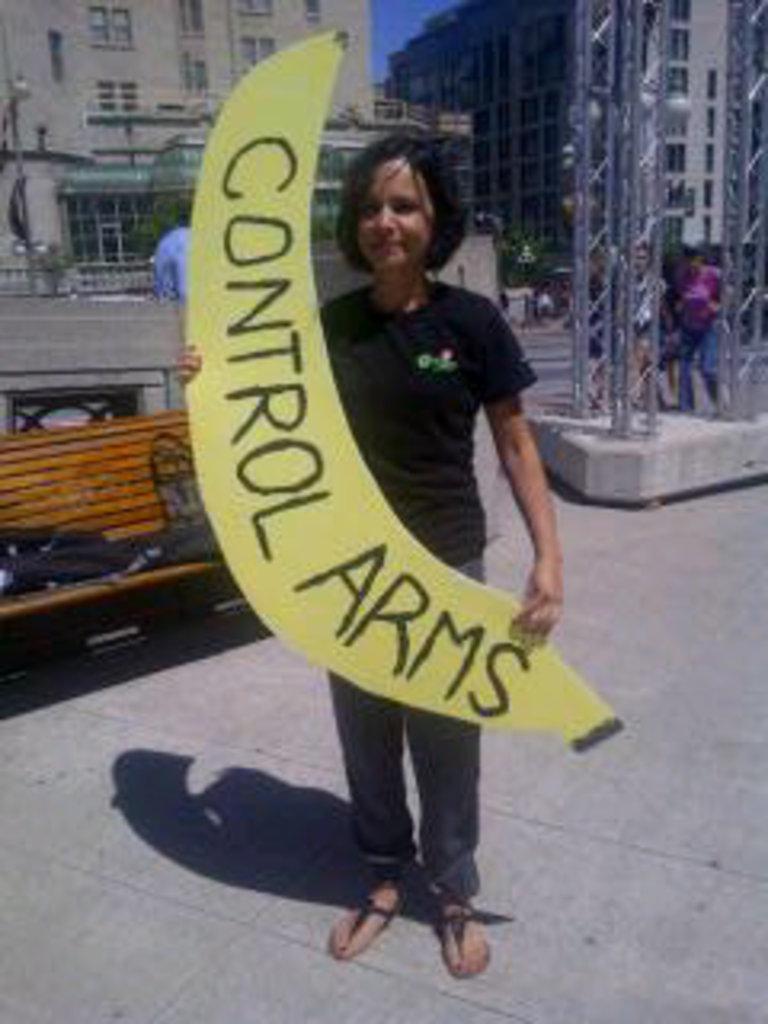Please provide a concise description of this image. As we can see in the image in the front there is a boy wearing black color t shirt and holding a banner. There is bench, few people here and there and building. 